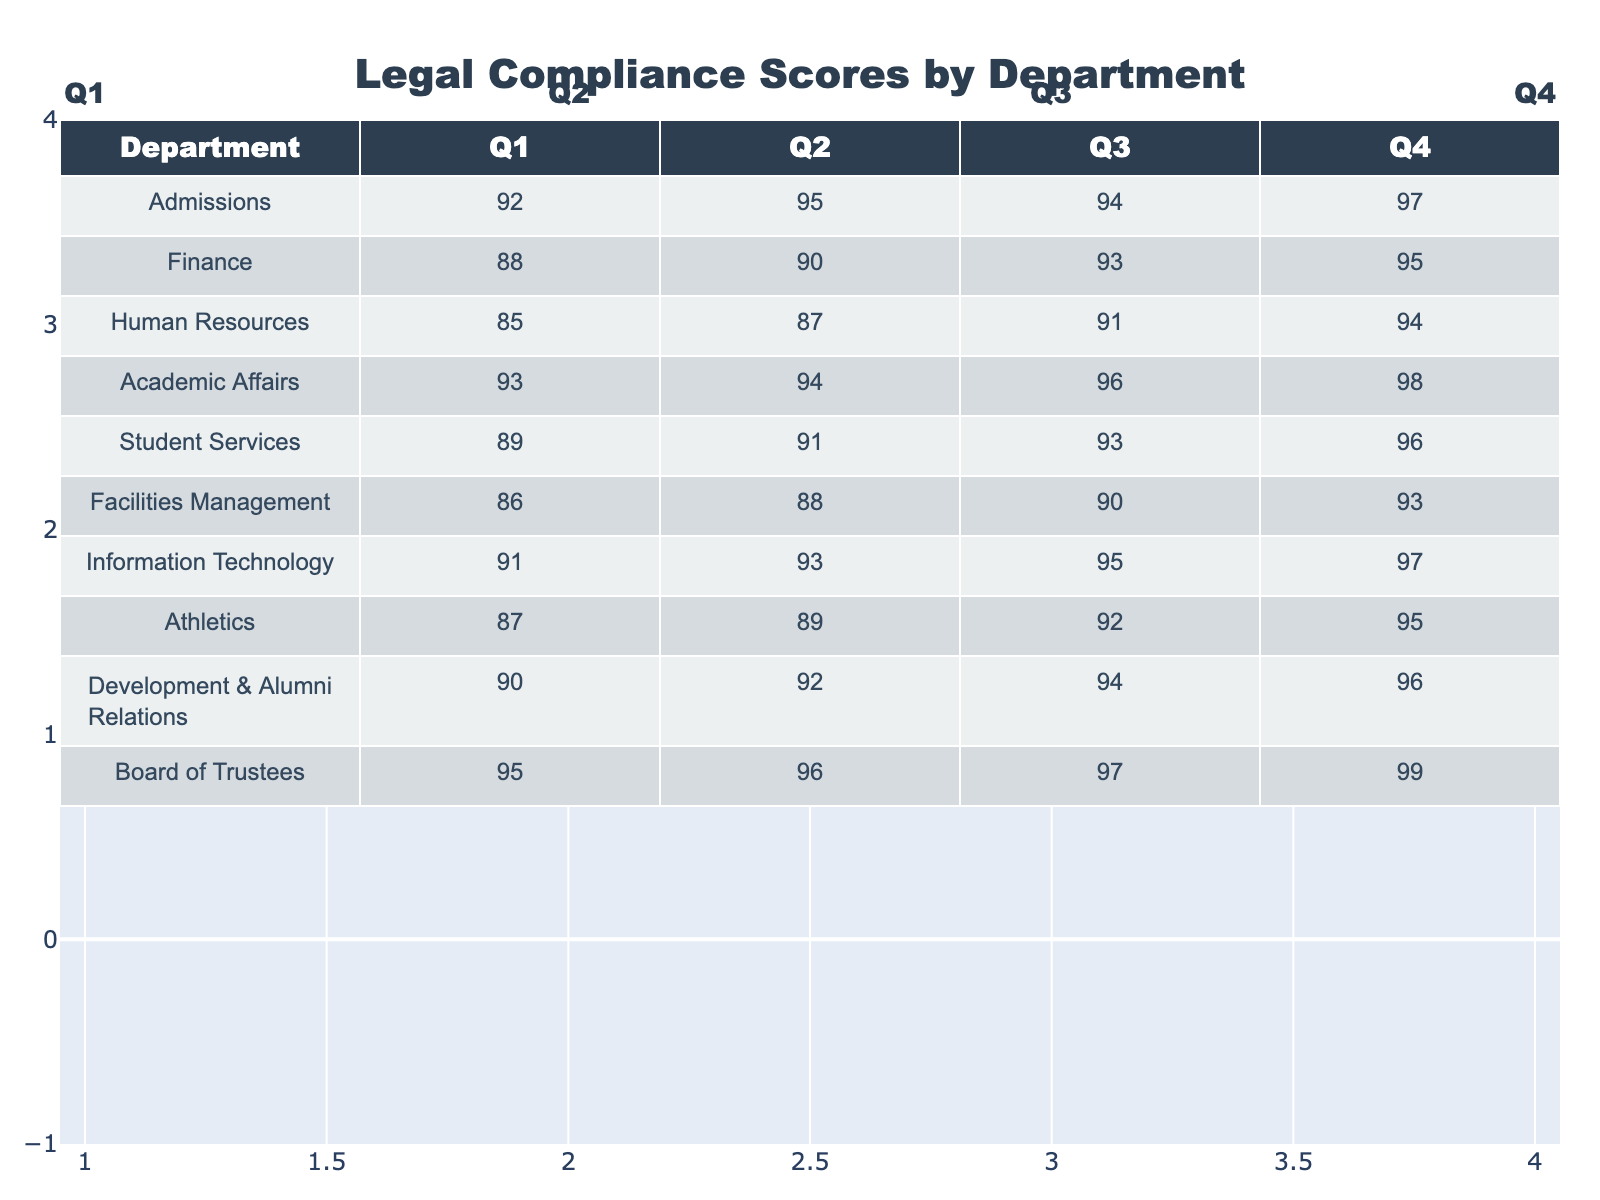What is the legal compliance score for the Admissions department in Q2? The Admissions department's score for Q2 is listed directly in the table under the Q2 column. The value is 95.
Answer: 95 Which department had the highest legal compliance score in Q4? By comparing the scores in the Q4 column for all departments, Academic Affairs has the highest score of 98.
Answer: Academic Affairs What is the average legal compliance score for the Finance department across all quarters? To find the average for Finance, add the scores: 88 + 90 + 93 + 95 = 366, then divide by 4 (the number of quarters), resulting in 366/4 = 91.5.
Answer: 91.5 Did the Facilities Management department improve its legal compliance score from Q1 to Q4? The score for Facilities Management in Q1 is 86 and in Q4 is 93. Since 93 is greater than 86, it shows an improvement.
Answer: Yes Which department saw the greatest increase in legal compliance scores from Q1 to Q4? The increases are as follows: Admissions (5), Finance (7), Human Resources (9), Academic Affairs (5), Student Services (7), Facilities Management (7), Information Technology (6), Athletics (8), Development & Alumni Relations (6), and Board of Trustees (4). The greatest increase is for Human Resources with an increase of 9 points.
Answer: Human Resources What was the median legal compliance score for all departments in Q3? The Q3 scores are: 94, 93, 91, 96, 90, 95, 92, 94, 96, 97. When sorted, the middle values are 94 and 94, so the median is 94.
Answer: 94 Which two departments consistently scored above 90 in all quarters? Reviewing each department's scores across all quarters, Admissions and Academic Affairs both scored above 90 in Q1, Q2, Q3, and Q4.
Answer: Admissions and Academic Affairs Is the Board of Trustees' legal compliance score higher than that of the Athletics department in every quarter? Comparing the scores: Board of Trustees (95, 96, 97, 99) and Athletics (87, 89, 92, 95), the Board of Trustees has a higher score in Q1, Q2, Q3, and Q4.
Answer: Yes What was the total legal compliance score for the Student Services department over the four quarters? The total is calculated by adding the scores: 89 + 91 + 93 + 96 = 369.
Answer: 369 In which quarter did Human Resources achieve its lowest legal compliance score? The Q1 to Q4 scores for Human Resources are 85, 87, 91, and 94. The lowest score is 85 in Q1.
Answer: Q1 